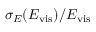<formula> <loc_0><loc_0><loc_500><loc_500>\sigma _ { E } ( E _ { v i s } ) / E _ { v i s }</formula> 